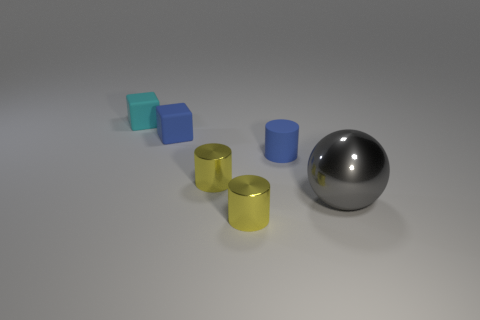Subtract all tiny blue matte cylinders. How many cylinders are left? 2 Add 3 small green metal cylinders. How many objects exist? 9 Subtract all yellow cylinders. How many cylinders are left? 1 Subtract all blocks. Subtract all metal objects. How many objects are left? 1 Add 5 small blue cylinders. How many small blue cylinders are left? 6 Add 1 tiny objects. How many tiny objects exist? 6 Subtract 0 purple spheres. How many objects are left? 6 Subtract all cubes. How many objects are left? 4 Subtract all blue cubes. Subtract all brown cylinders. How many cubes are left? 1 Subtract all green balls. How many yellow cylinders are left? 2 